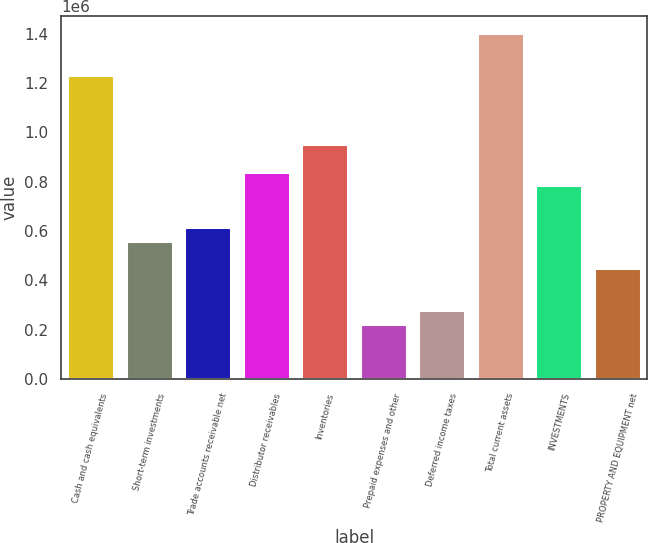Convert chart. <chart><loc_0><loc_0><loc_500><loc_500><bar_chart><fcel>Cash and cash equivalents<fcel>Short-term investments<fcel>Trade accounts receivable net<fcel>Distributor receivables<fcel>Inventories<fcel>Prepaid expenses and other<fcel>Deferred income taxes<fcel>Total current assets<fcel>INVESTMENTS<fcel>PROPERTY AND EQUIPMENT net<nl><fcel>1.23433e+06<fcel>561324<fcel>617408<fcel>841744<fcel>953912<fcel>224820<fcel>280904<fcel>1.40258e+06<fcel>785660<fcel>449156<nl></chart> 